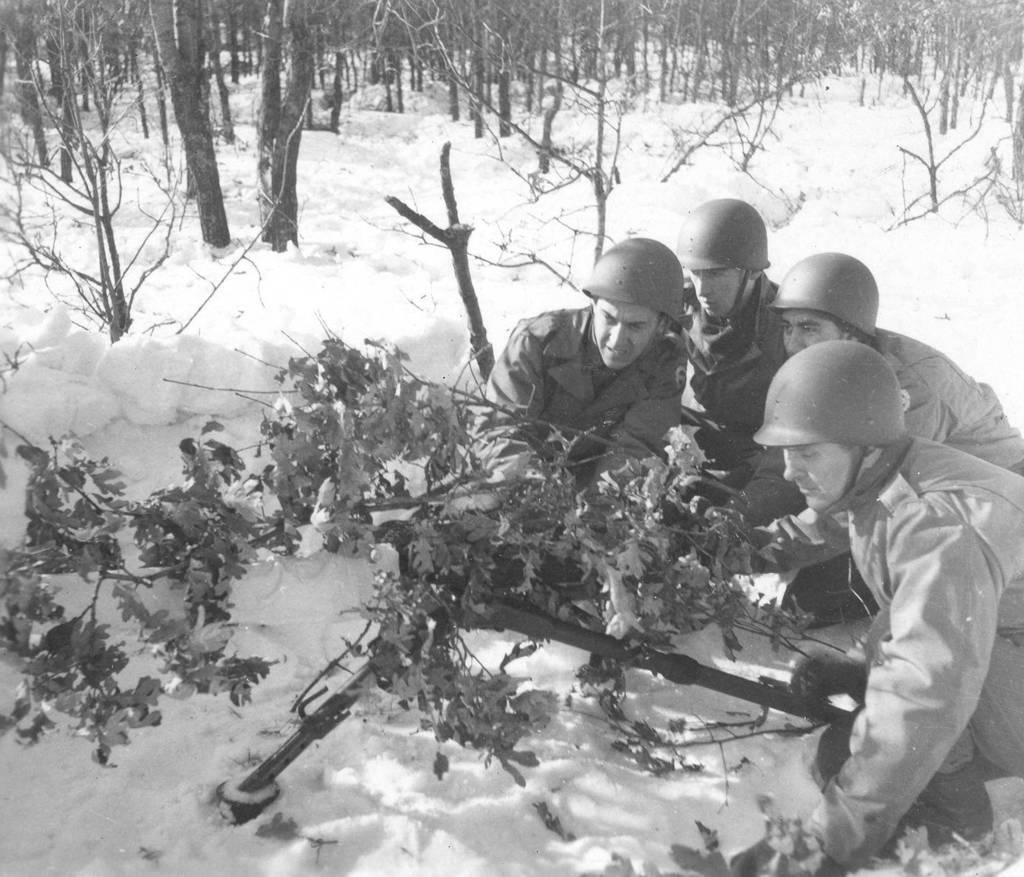What is the color scheme of the image? The image is black and white. Who or what can be seen in the image? There are people in the image. What are the people wearing on their heads? The people are wearing helmets. What type of clothing are the people wearing? The people are wearing jackets. What type of natural environment is visible in the image? There are trees in the image. What is the ground covered with at the bottom of the image? There is snow at the bottom of the image. What type of wave can be seen crashing on the shore in the image? There is no wave or shore visible in the image; it is a black and white image featuring people wearing helmets and jackets, trees, and snow. What smell is associated with the image? There is no information about smells in the image, as it is a visual medium. 